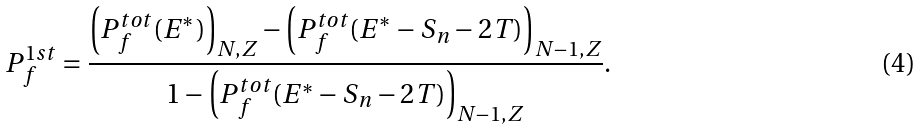<formula> <loc_0><loc_0><loc_500><loc_500>P _ { f } ^ { 1 s t } = \frac { \left ( P _ { f } ^ { t o t } ( E ^ { * } ) \right ) _ { N , Z } - \left ( P _ { f } ^ { t o t } ( E ^ { * } - S _ { n } - 2 T ) \right ) _ { N - 1 , Z } } { 1 - \left ( P _ { f } ^ { t o t } ( E ^ { * } - S _ { n } - 2 T ) \right ) _ { N - 1 , Z } } .</formula> 